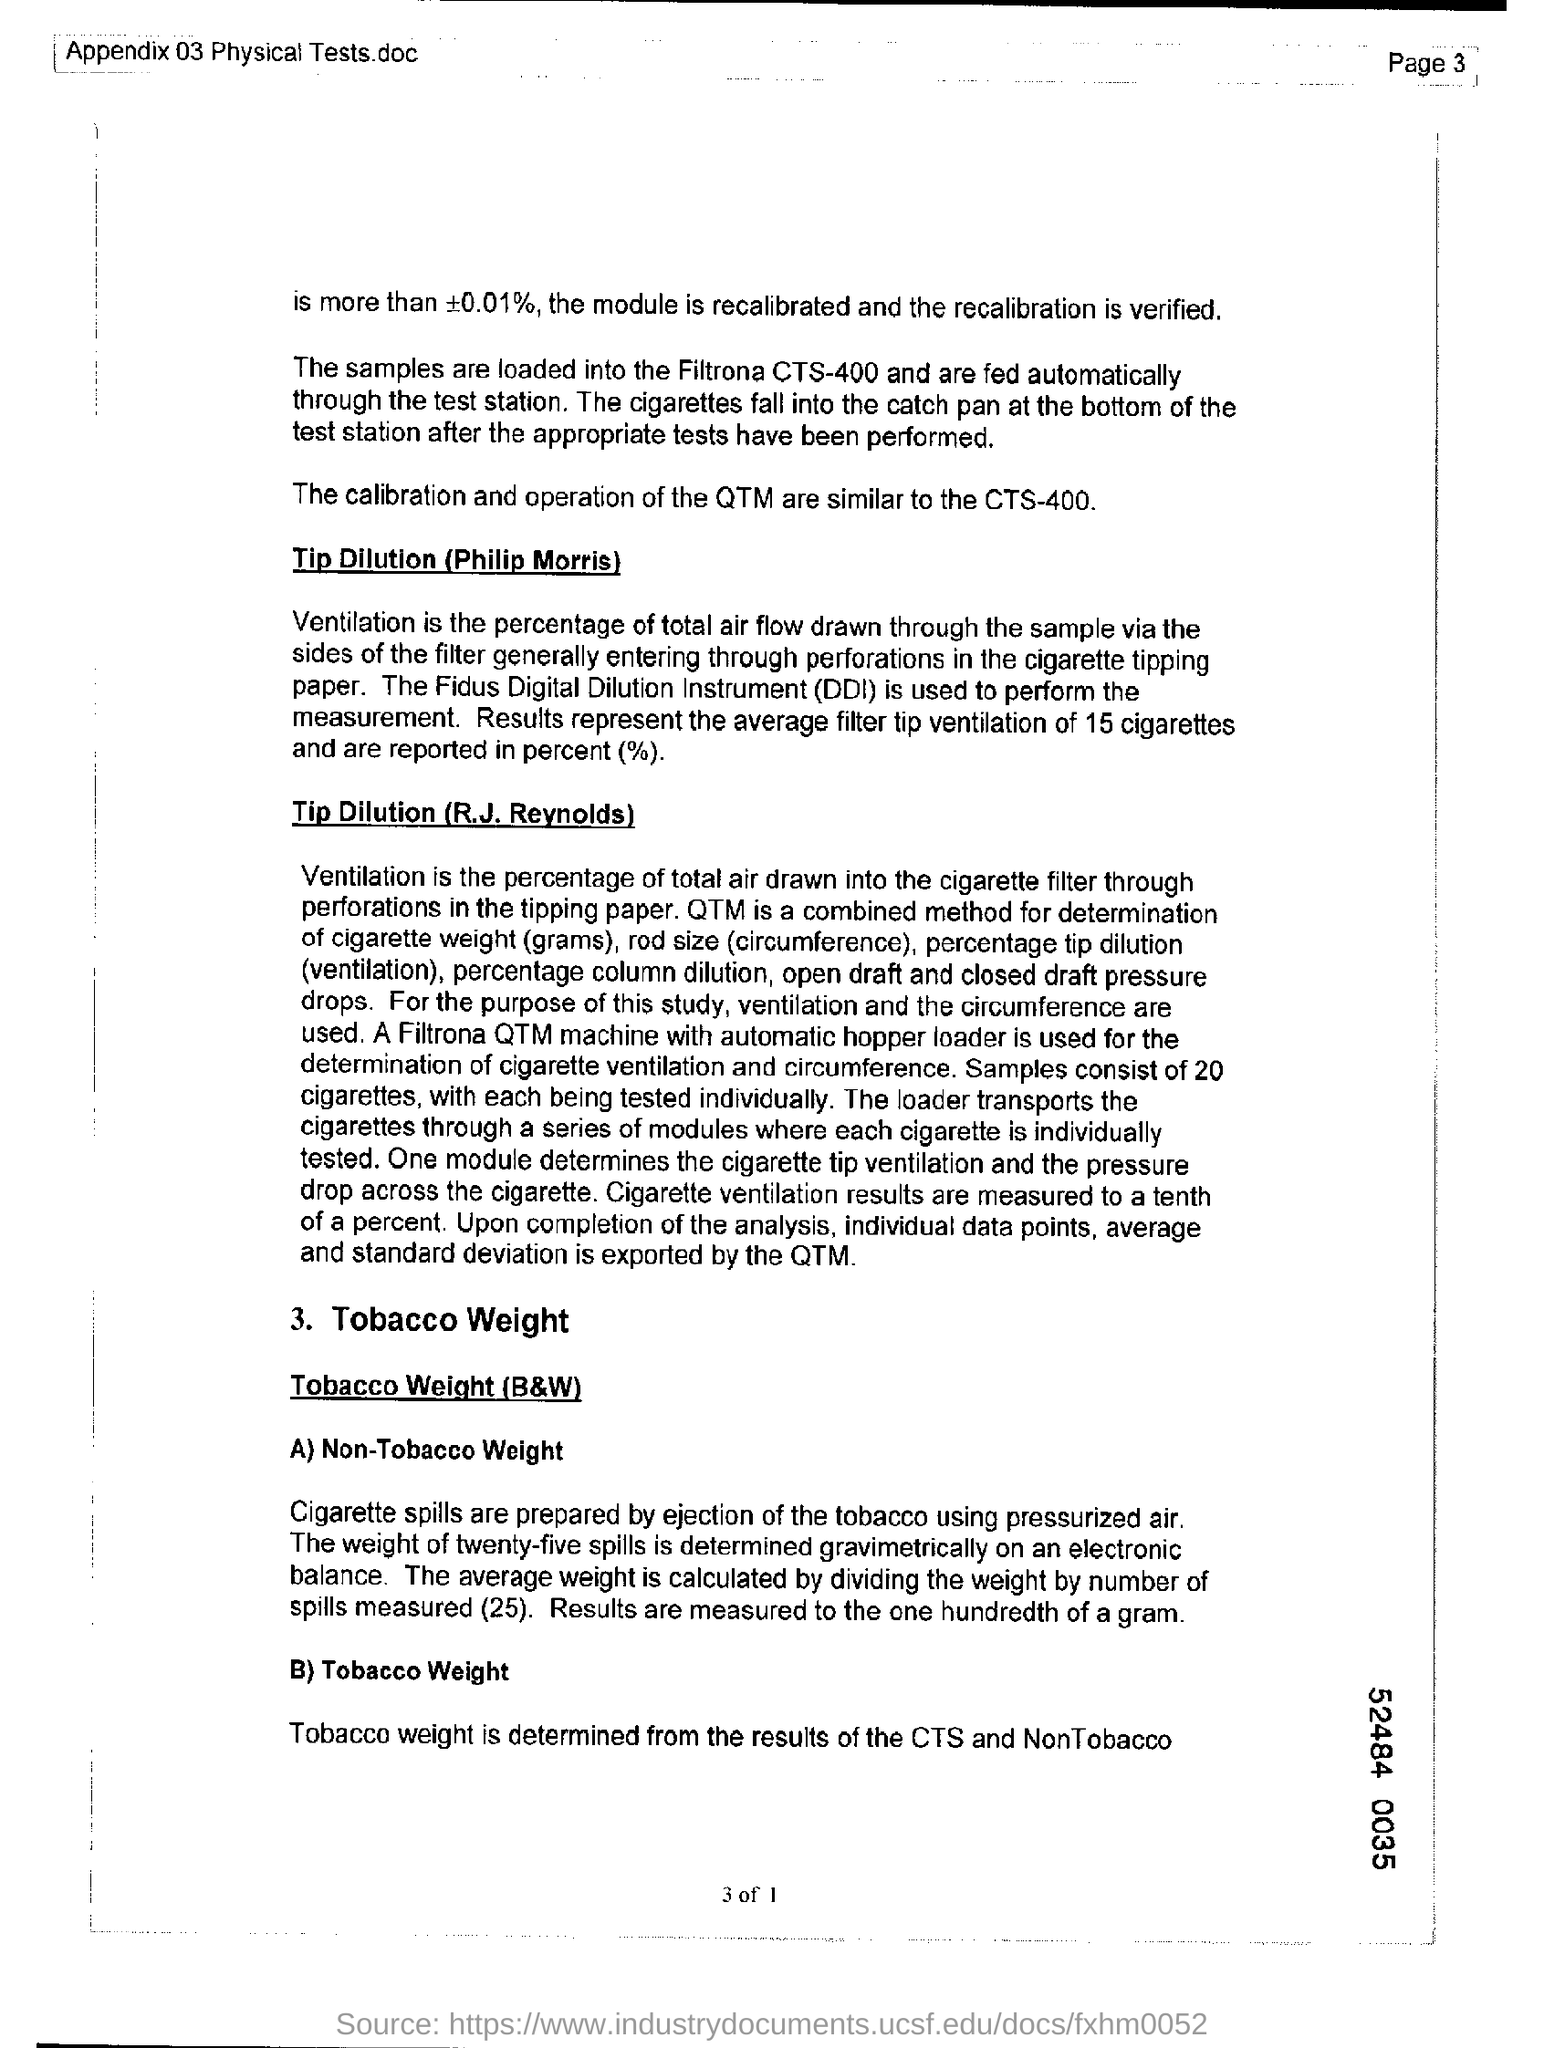What is the fullform of DDI?
Your response must be concise. Digital Dilution Instrument. 